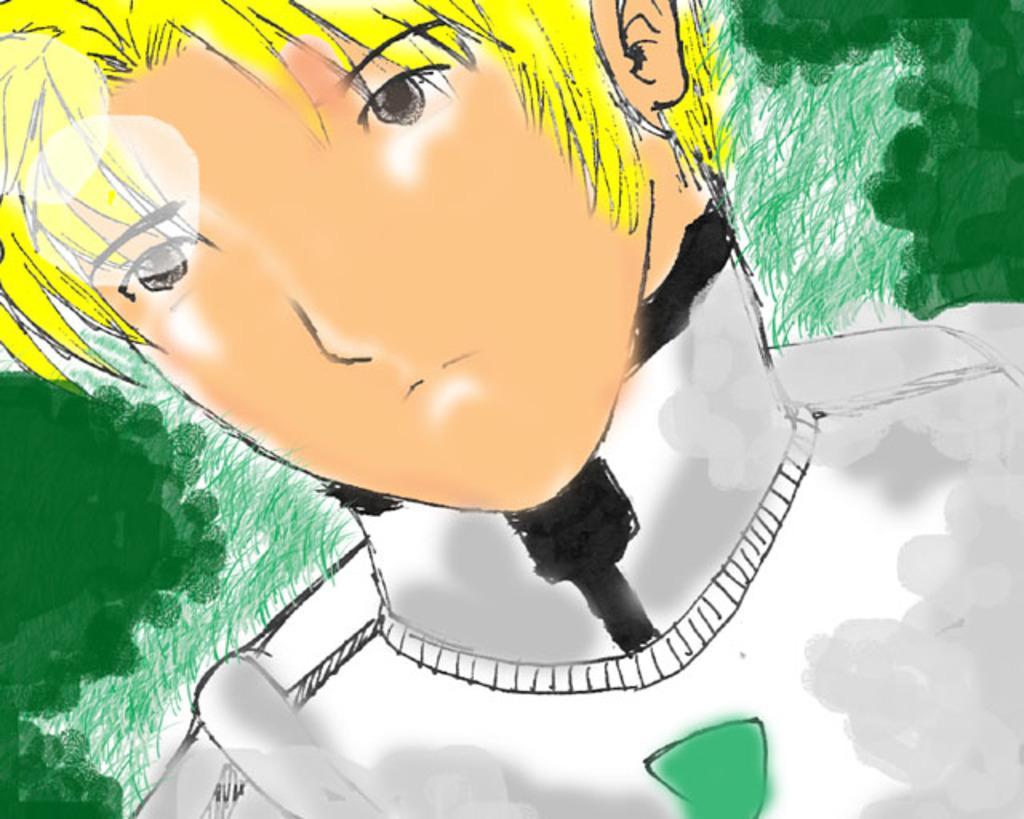Can you describe this image briefly? It is a graphical image. In the center of the image we can see one person. And we can see the green and white colored background. 